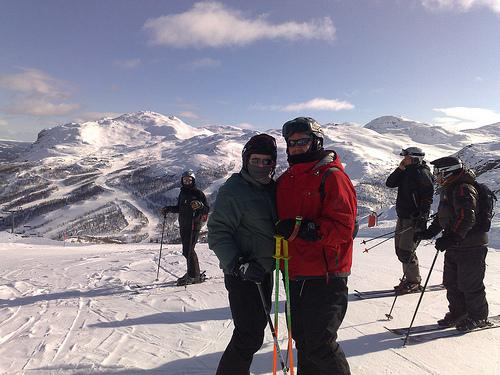Question: what season is it?
Choices:
A. Fall.
B. Spring.
C. Winter.
D. Summer.
Answer with the letter. Answer: C Question: where are the mountains?
Choices:
A. Foreground.
B. Hidden behind trees.
C. There are none.
D. Background.
Answer with the letter. Answer: D Question: who is in the picture?
Choices:
A. Skaters.
B. Skiers.
C. Runners.
D. Climbers.
Answer with the letter. Answer: B Question: what is on the ground?
Choices:
A. Grass.
B. Gravel.
C. Snow.
D. Sand.
Answer with the letter. Answer: C Question: how do the skiers push themselves?
Choices:
A. Small propulsion engines.
B. Poles.
C. Paddles.
D. Wind.
Answer with the letter. Answer: B Question: what color coat is the man in front wearing?
Choices:
A. Red.
B. Blue.
C. Yellow.
D. White.
Answer with the letter. Answer: A Question: what are the markings from on the ground?
Choices:
A. Animals.
B. Skis.
C. Cars.
D. Shoes.
Answer with the letter. Answer: B Question: what kind of temperature is in the picture?
Choices:
A. Very hot.
B. Warm.
C. Cold.
D. Temperate.
Answer with the letter. Answer: C 